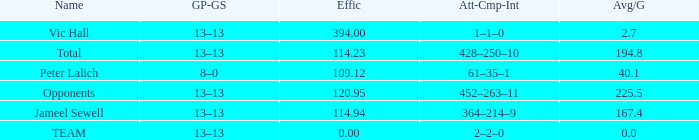Avg/G that has a Att-Cmp-Int of 1–1–0, and an Effic larger than 394 is what total? 0.0. 